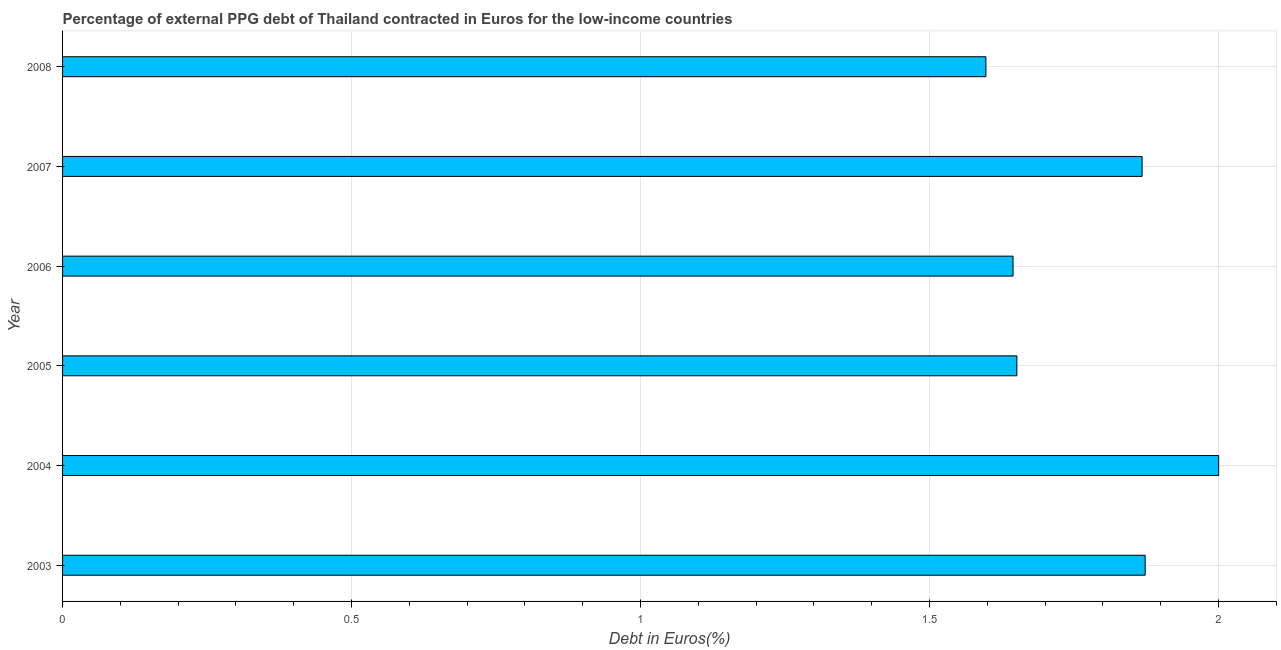What is the title of the graph?
Ensure brevity in your answer.  Percentage of external PPG debt of Thailand contracted in Euros for the low-income countries. What is the label or title of the X-axis?
Your response must be concise. Debt in Euros(%). What is the label or title of the Y-axis?
Provide a succinct answer. Year. What is the currency composition of ppg debt in 2006?
Your response must be concise. 1.64. Across all years, what is the maximum currency composition of ppg debt?
Your answer should be very brief. 2. Across all years, what is the minimum currency composition of ppg debt?
Your answer should be compact. 1.6. In which year was the currency composition of ppg debt minimum?
Give a very brief answer. 2008. What is the sum of the currency composition of ppg debt?
Give a very brief answer. 10.64. What is the difference between the currency composition of ppg debt in 2004 and 2007?
Your response must be concise. 0.13. What is the average currency composition of ppg debt per year?
Provide a succinct answer. 1.77. What is the median currency composition of ppg debt?
Give a very brief answer. 1.76. In how many years, is the currency composition of ppg debt greater than 0.9 %?
Provide a succinct answer. 6. Do a majority of the years between 2003 and 2005 (inclusive) have currency composition of ppg debt greater than 1 %?
Provide a short and direct response. Yes. What is the ratio of the currency composition of ppg debt in 2003 to that in 2006?
Provide a short and direct response. 1.14. What is the difference between the highest and the second highest currency composition of ppg debt?
Make the answer very short. 0.13. Is the sum of the currency composition of ppg debt in 2005 and 2008 greater than the maximum currency composition of ppg debt across all years?
Offer a terse response. Yes. In how many years, is the currency composition of ppg debt greater than the average currency composition of ppg debt taken over all years?
Provide a succinct answer. 3. Are all the bars in the graph horizontal?
Ensure brevity in your answer.  Yes. How many years are there in the graph?
Your answer should be compact. 6. What is the difference between two consecutive major ticks on the X-axis?
Ensure brevity in your answer.  0.5. Are the values on the major ticks of X-axis written in scientific E-notation?
Ensure brevity in your answer.  No. What is the Debt in Euros(%) of 2003?
Give a very brief answer. 1.87. What is the Debt in Euros(%) of 2004?
Ensure brevity in your answer.  2. What is the Debt in Euros(%) of 2005?
Offer a terse response. 1.65. What is the Debt in Euros(%) of 2006?
Make the answer very short. 1.64. What is the Debt in Euros(%) of 2007?
Your answer should be very brief. 1.87. What is the Debt in Euros(%) in 2008?
Keep it short and to the point. 1.6. What is the difference between the Debt in Euros(%) in 2003 and 2004?
Make the answer very short. -0.13. What is the difference between the Debt in Euros(%) in 2003 and 2005?
Keep it short and to the point. 0.22. What is the difference between the Debt in Euros(%) in 2003 and 2006?
Your answer should be compact. 0.23. What is the difference between the Debt in Euros(%) in 2003 and 2007?
Keep it short and to the point. 0.01. What is the difference between the Debt in Euros(%) in 2003 and 2008?
Offer a terse response. 0.28. What is the difference between the Debt in Euros(%) in 2004 and 2005?
Offer a terse response. 0.35. What is the difference between the Debt in Euros(%) in 2004 and 2006?
Provide a succinct answer. 0.36. What is the difference between the Debt in Euros(%) in 2004 and 2007?
Provide a succinct answer. 0.13. What is the difference between the Debt in Euros(%) in 2004 and 2008?
Your answer should be compact. 0.4. What is the difference between the Debt in Euros(%) in 2005 and 2006?
Provide a short and direct response. 0.01. What is the difference between the Debt in Euros(%) in 2005 and 2007?
Your answer should be very brief. -0.22. What is the difference between the Debt in Euros(%) in 2005 and 2008?
Give a very brief answer. 0.05. What is the difference between the Debt in Euros(%) in 2006 and 2007?
Offer a terse response. -0.22. What is the difference between the Debt in Euros(%) in 2006 and 2008?
Ensure brevity in your answer.  0.05. What is the difference between the Debt in Euros(%) in 2007 and 2008?
Your answer should be compact. 0.27. What is the ratio of the Debt in Euros(%) in 2003 to that in 2004?
Make the answer very short. 0.94. What is the ratio of the Debt in Euros(%) in 2003 to that in 2005?
Give a very brief answer. 1.13. What is the ratio of the Debt in Euros(%) in 2003 to that in 2006?
Ensure brevity in your answer.  1.14. What is the ratio of the Debt in Euros(%) in 2003 to that in 2007?
Offer a very short reply. 1. What is the ratio of the Debt in Euros(%) in 2003 to that in 2008?
Your answer should be very brief. 1.17. What is the ratio of the Debt in Euros(%) in 2004 to that in 2005?
Your answer should be very brief. 1.21. What is the ratio of the Debt in Euros(%) in 2004 to that in 2006?
Give a very brief answer. 1.22. What is the ratio of the Debt in Euros(%) in 2004 to that in 2007?
Provide a short and direct response. 1.07. What is the ratio of the Debt in Euros(%) in 2004 to that in 2008?
Give a very brief answer. 1.25. What is the ratio of the Debt in Euros(%) in 2005 to that in 2007?
Your answer should be very brief. 0.88. What is the ratio of the Debt in Euros(%) in 2005 to that in 2008?
Your response must be concise. 1.03. What is the ratio of the Debt in Euros(%) in 2006 to that in 2008?
Offer a terse response. 1.03. What is the ratio of the Debt in Euros(%) in 2007 to that in 2008?
Offer a very short reply. 1.17. 